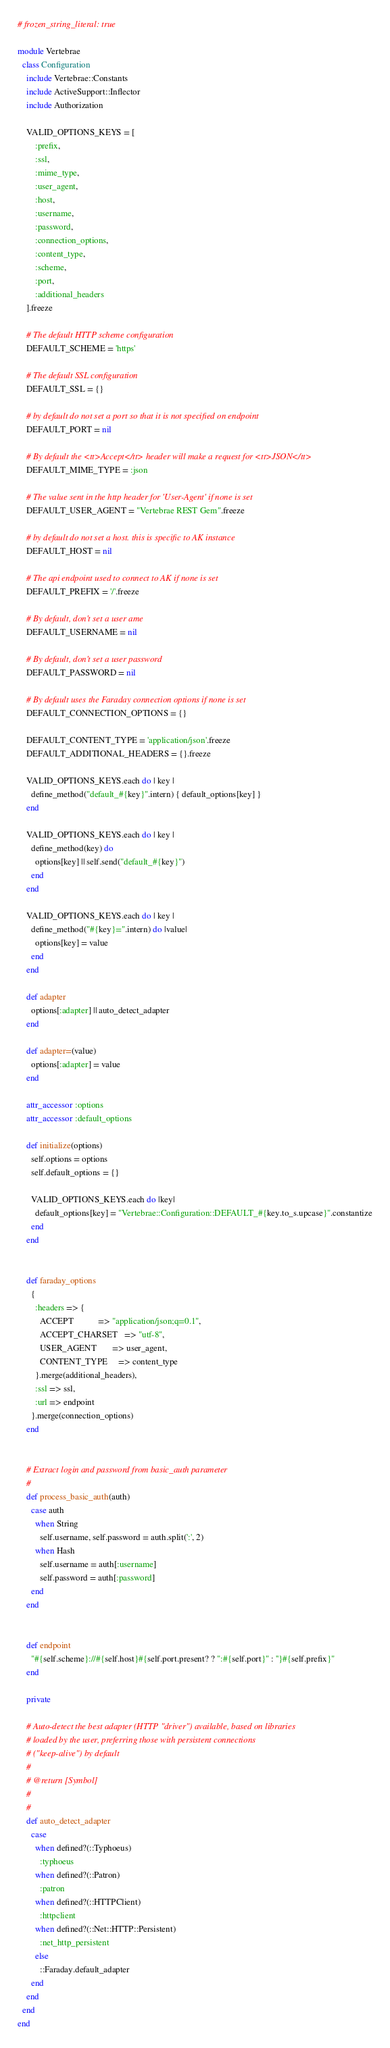<code> <loc_0><loc_0><loc_500><loc_500><_Ruby_># frozen_string_literal: true

module Vertebrae
  class Configuration
    include Vertebrae::Constants
    include ActiveSupport::Inflector
    include Authorization

    VALID_OPTIONS_KEYS = [
        :prefix,
        :ssl,
        :mime_type,
        :user_agent,
        :host,
        :username,
        :password,
        :connection_options,
        :content_type,
        :scheme,
        :port,
        :additional_headers
    ].freeze

    # The default HTTP scheme configuration
    DEFAULT_SCHEME = 'https'

    # The default SSL configuration
    DEFAULT_SSL = {}

    # by default do not set a port so that it is not specified on endpoint
    DEFAULT_PORT = nil

    # By default the <tt>Accept</tt> header will make a request for <tt>JSON</tt>
    DEFAULT_MIME_TYPE = :json

    # The value sent in the http header for 'User-Agent' if none is set
    DEFAULT_USER_AGENT = "Vertebrae REST Gem".freeze

    # by default do not set a host. this is specific to AK instance
    DEFAULT_HOST = nil

    # The api endpoint used to connect to AK if none is set
    DEFAULT_PREFIX = '/'.freeze

    # By default, don't set a user ame
    DEFAULT_USERNAME = nil

    # By default, don't set a user password
    DEFAULT_PASSWORD = nil

    # By default uses the Faraday connection options if none is set
    DEFAULT_CONNECTION_OPTIONS = {}

    DEFAULT_CONTENT_TYPE = 'application/json'.freeze
    DEFAULT_ADDITIONAL_HEADERS = {}.freeze

    VALID_OPTIONS_KEYS.each do | key |
      define_method("default_#{key}".intern) { default_options[key] }
    end

    VALID_OPTIONS_KEYS.each do | key |
      define_method(key) do
        options[key] || self.send("default_#{key}")
      end
    end

    VALID_OPTIONS_KEYS.each do | key |
      define_method("#{key}=".intern) do |value|
        options[key] = value
      end
    end

    def adapter
      options[:adapter] || auto_detect_adapter
    end

    def adapter=(value)
      options[:adapter] = value
    end

    attr_accessor :options
    attr_accessor :default_options

    def initialize(options)
      self.options = options
      self.default_options = {}

      VALID_OPTIONS_KEYS.each do |key|
        default_options[key] = "Vertebrae::Configuration::DEFAULT_#{key.to_s.upcase}".constantize
      end
    end


    def faraday_options
      {
        :headers => {
          ACCEPT           => "application/json;q=0.1",
          ACCEPT_CHARSET   => "utf-8",
          USER_AGENT       => user_agent,
          CONTENT_TYPE     => content_type
        }.merge(additional_headers),
        :ssl => ssl,
        :url => endpoint
      }.merge(connection_options)
    end


    # Extract login and password from basic_auth parameter
    #
    def process_basic_auth(auth)
      case auth
        when String
          self.username, self.password = auth.split(':', 2)
        when Hash
          self.username = auth[:username]
          self.password = auth[:password]
      end
    end


    def endpoint
      "#{self.scheme}://#{self.host}#{self.port.present? ? ":#{self.port}" : ''}#{self.prefix}"
    end

    private

    # Auto-detect the best adapter (HTTP "driver") available, based on libraries
    # loaded by the user, preferring those with persistent connections
    # ("keep-alive") by default
    #
    # @return [Symbol]
    #
    #
    def auto_detect_adapter
      case
        when defined?(::Typhoeus)
          :typhoeus
        when defined?(::Patron)
          :patron
        when defined?(::HTTPClient)
          :httpclient
        when defined?(::Net::HTTP::Persistent)
          :net_http_persistent
        else
          ::Faraday.default_adapter
      end
    end
  end
end
</code> 